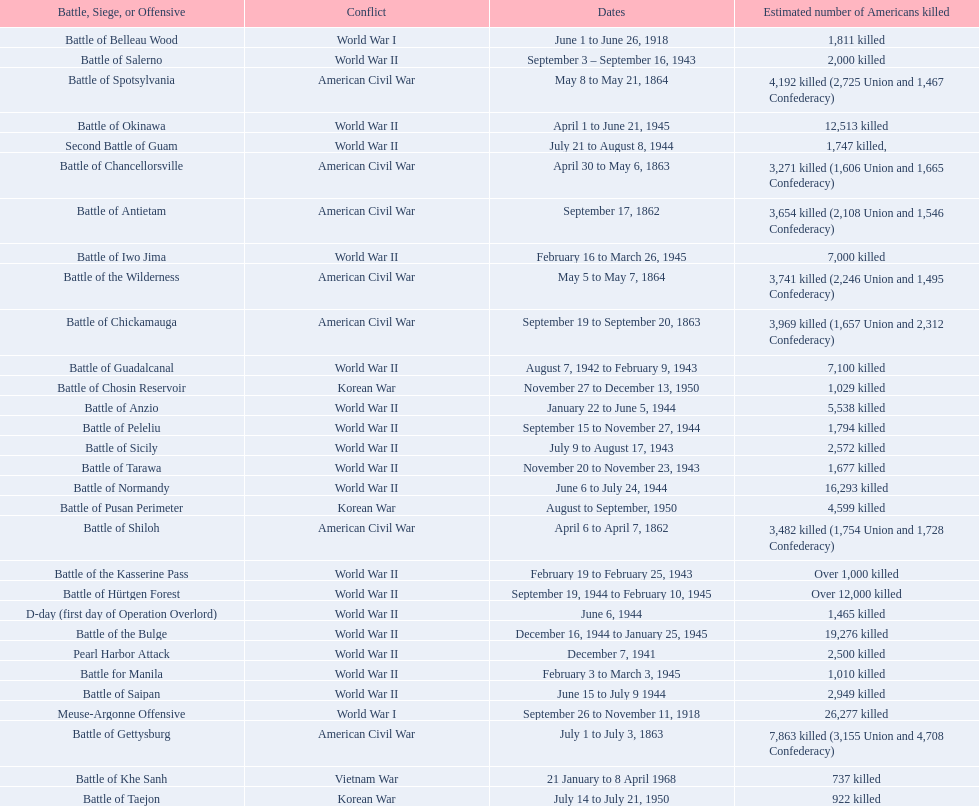How many battles resulted between 3,000 and 4,200 estimated americans killed? 6. 